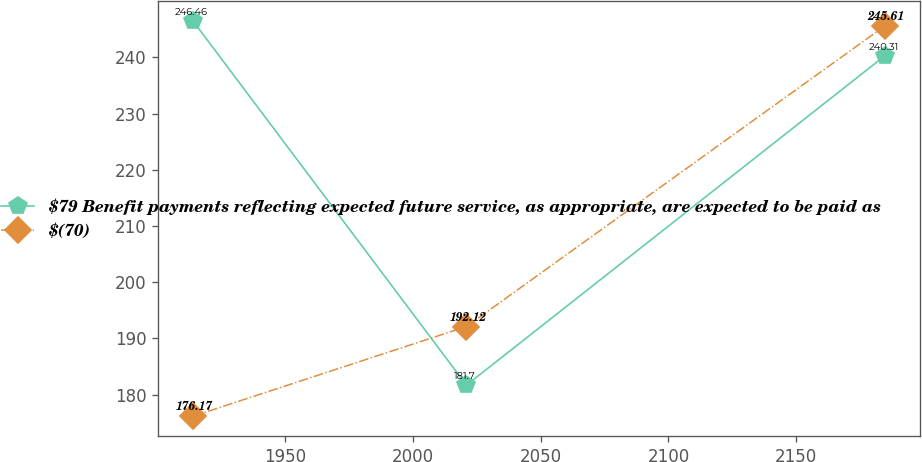Convert chart to OTSL. <chart><loc_0><loc_0><loc_500><loc_500><line_chart><ecel><fcel>$79 Benefit payments reflecting expected future service, as appropriate, are expected to be paid as<fcel>$(70)<nl><fcel>1914.15<fcel>246.46<fcel>176.17<nl><fcel>2021.05<fcel>181.7<fcel>192.12<nl><fcel>2184.7<fcel>240.31<fcel>245.61<nl></chart> 